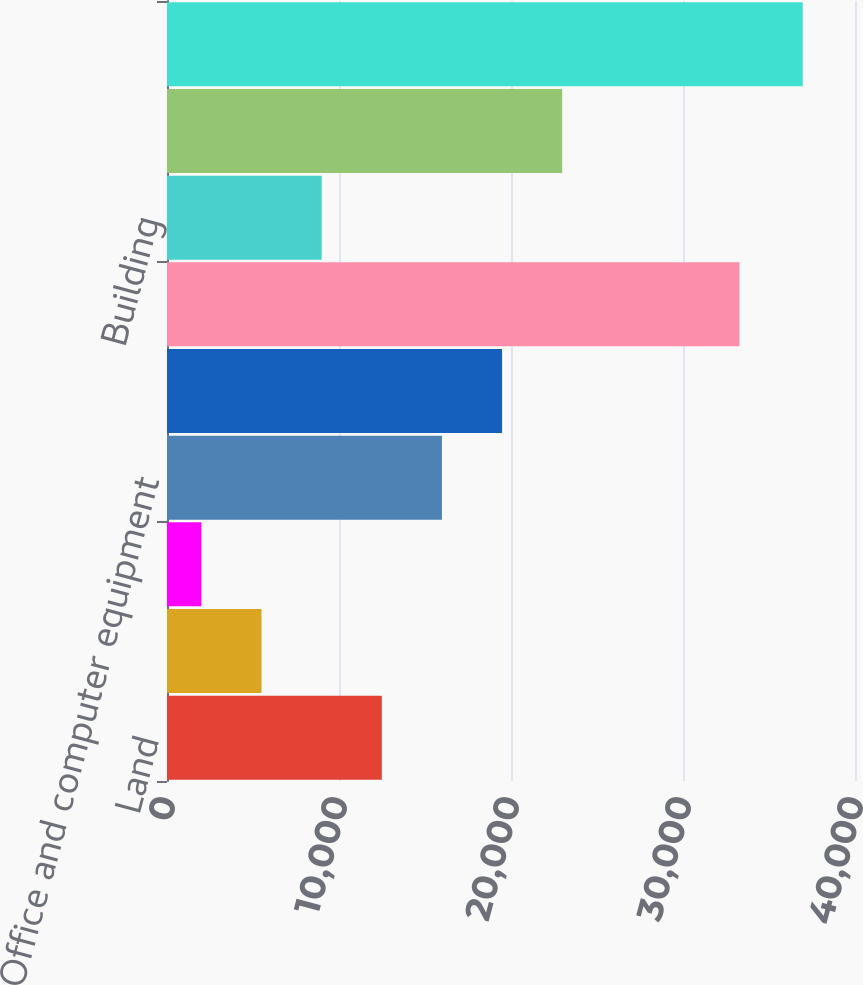Convert chart to OTSL. <chart><loc_0><loc_0><loc_500><loc_500><bar_chart><fcel>Land<fcel>Leasehold improvements<fcel>Furniture and fixtures<fcel>Office and computer equipment<fcel>Computer software<fcel>Equipment<fcel>Building<fcel>Vehicles<fcel>Less accumulated depreciation<nl><fcel>12488.3<fcel>5496.1<fcel>2000<fcel>15984.4<fcel>19480.5<fcel>33286<fcel>8992.2<fcel>22976.6<fcel>36961<nl></chart> 